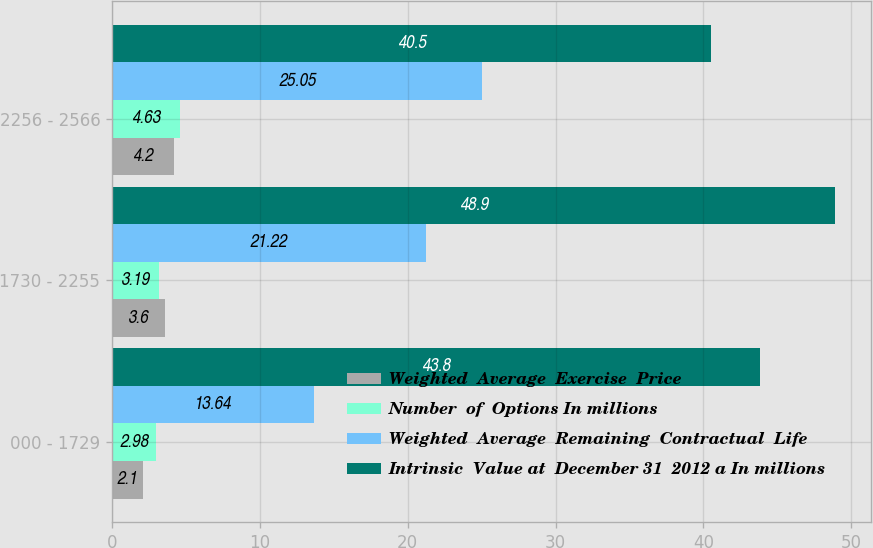Convert chart to OTSL. <chart><loc_0><loc_0><loc_500><loc_500><stacked_bar_chart><ecel><fcel>000 - 1729<fcel>1730 - 2255<fcel>2256 - 2566<nl><fcel>Weighted  Average  Exercise  Price<fcel>2.1<fcel>3.6<fcel>4.2<nl><fcel>Number  of  Options In millions<fcel>2.98<fcel>3.19<fcel>4.63<nl><fcel>Weighted  Average  Remaining  Contractual  Life<fcel>13.64<fcel>21.22<fcel>25.05<nl><fcel>Intrinsic  Value at  December 31  2012 a In millions<fcel>43.8<fcel>48.9<fcel>40.5<nl></chart> 